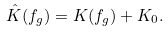Convert formula to latex. <formula><loc_0><loc_0><loc_500><loc_500>\hat { K } ( f _ { g } ) = K ( f _ { g } ) + K _ { 0 } .</formula> 